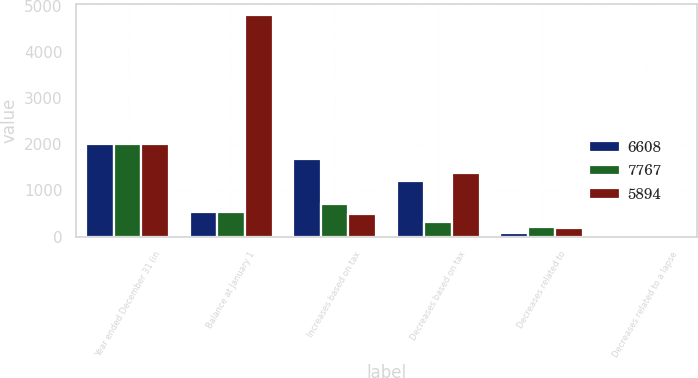<chart> <loc_0><loc_0><loc_500><loc_500><stacked_bar_chart><ecel><fcel>Year ended December 31 (in<fcel>Balance at January 1<fcel>Increases based on tax<fcel>Decreases based on tax<fcel>Decreases related to<fcel>Decreases related to a lapse<nl><fcel>6608<fcel>2010<fcel>542.5<fcel>1681<fcel>1198<fcel>74<fcel>39<nl><fcel>7767<fcel>2009<fcel>542.5<fcel>703<fcel>322<fcel>203<fcel>42<nl><fcel>5894<fcel>2008<fcel>4811<fcel>501<fcel>1386<fcel>181<fcel>19<nl></chart> 